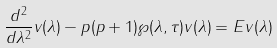Convert formula to latex. <formula><loc_0><loc_0><loc_500><loc_500>\frac { d ^ { 2 } } { d \lambda ^ { 2 } } v ( \lambda ) - p ( p + 1 ) { \wp } ( \lambda , \tau ) v ( \lambda ) = E v ( \lambda )</formula> 